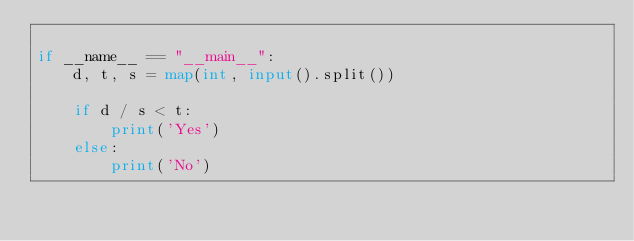<code> <loc_0><loc_0><loc_500><loc_500><_Python_>
if __name__ == "__main__":
    d, t, s = map(int, input().split())

    if d / s < t:
        print('Yes')
    else:
        print('No')

</code> 